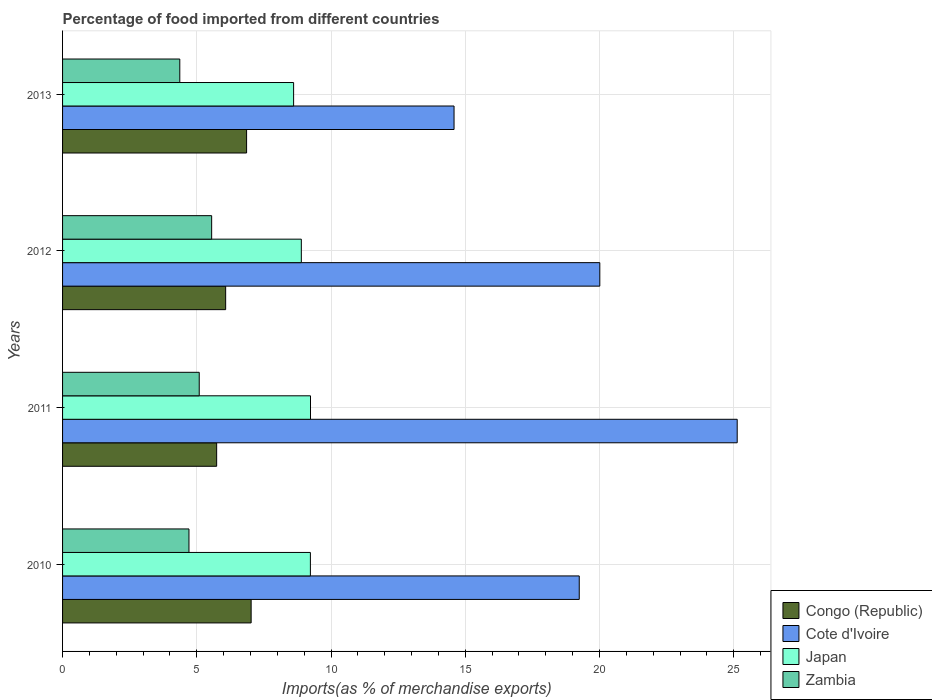Are the number of bars per tick equal to the number of legend labels?
Make the answer very short. Yes. Are the number of bars on each tick of the Y-axis equal?
Your answer should be compact. Yes. How many bars are there on the 2nd tick from the bottom?
Your answer should be compact. 4. What is the percentage of imports to different countries in Zambia in 2013?
Provide a short and direct response. 4.37. Across all years, what is the maximum percentage of imports to different countries in Cote d'Ivoire?
Ensure brevity in your answer.  25.13. Across all years, what is the minimum percentage of imports to different countries in Zambia?
Your answer should be compact. 4.37. In which year was the percentage of imports to different countries in Congo (Republic) maximum?
Keep it short and to the point. 2010. What is the total percentage of imports to different countries in Cote d'Ivoire in the graph?
Keep it short and to the point. 78.96. What is the difference between the percentage of imports to different countries in Zambia in 2011 and that in 2013?
Provide a succinct answer. 0.72. What is the difference between the percentage of imports to different countries in Cote d'Ivoire in 2010 and the percentage of imports to different countries in Zambia in 2011?
Keep it short and to the point. 14.15. What is the average percentage of imports to different countries in Cote d'Ivoire per year?
Provide a succinct answer. 19.74. In the year 2010, what is the difference between the percentage of imports to different countries in Zambia and percentage of imports to different countries in Congo (Republic)?
Provide a succinct answer. -2.32. What is the ratio of the percentage of imports to different countries in Cote d'Ivoire in 2010 to that in 2012?
Give a very brief answer. 0.96. Is the percentage of imports to different countries in Japan in 2012 less than that in 2013?
Give a very brief answer. No. Is the difference between the percentage of imports to different countries in Zambia in 2012 and 2013 greater than the difference between the percentage of imports to different countries in Congo (Republic) in 2012 and 2013?
Provide a short and direct response. Yes. What is the difference between the highest and the second highest percentage of imports to different countries in Cote d'Ivoire?
Keep it short and to the point. 5.12. What is the difference between the highest and the lowest percentage of imports to different countries in Cote d'Ivoire?
Your response must be concise. 10.55. Is the sum of the percentage of imports to different countries in Cote d'Ivoire in 2011 and 2013 greater than the maximum percentage of imports to different countries in Congo (Republic) across all years?
Keep it short and to the point. Yes. Is it the case that in every year, the sum of the percentage of imports to different countries in Zambia and percentage of imports to different countries in Congo (Republic) is greater than the sum of percentage of imports to different countries in Japan and percentage of imports to different countries in Cote d'Ivoire?
Your response must be concise. No. What does the 1st bar from the top in 2013 represents?
Keep it short and to the point. Zambia. What does the 2nd bar from the bottom in 2013 represents?
Make the answer very short. Cote d'Ivoire. Is it the case that in every year, the sum of the percentage of imports to different countries in Congo (Republic) and percentage of imports to different countries in Cote d'Ivoire is greater than the percentage of imports to different countries in Zambia?
Your answer should be compact. Yes. Are all the bars in the graph horizontal?
Keep it short and to the point. Yes. What is the difference between two consecutive major ticks on the X-axis?
Offer a terse response. 5. Are the values on the major ticks of X-axis written in scientific E-notation?
Offer a very short reply. No. Where does the legend appear in the graph?
Offer a very short reply. Bottom right. How are the legend labels stacked?
Your answer should be very brief. Vertical. What is the title of the graph?
Ensure brevity in your answer.  Percentage of food imported from different countries. Does "Ireland" appear as one of the legend labels in the graph?
Provide a succinct answer. No. What is the label or title of the X-axis?
Make the answer very short. Imports(as % of merchandise exports). What is the label or title of the Y-axis?
Your answer should be compact. Years. What is the Imports(as % of merchandise exports) in Congo (Republic) in 2010?
Offer a very short reply. 7.02. What is the Imports(as % of merchandise exports) in Cote d'Ivoire in 2010?
Provide a succinct answer. 19.24. What is the Imports(as % of merchandise exports) in Japan in 2010?
Keep it short and to the point. 9.23. What is the Imports(as % of merchandise exports) in Zambia in 2010?
Your response must be concise. 4.71. What is the Imports(as % of merchandise exports) of Congo (Republic) in 2011?
Offer a very short reply. 5.74. What is the Imports(as % of merchandise exports) of Cote d'Ivoire in 2011?
Make the answer very short. 25.13. What is the Imports(as % of merchandise exports) of Japan in 2011?
Ensure brevity in your answer.  9.23. What is the Imports(as % of merchandise exports) of Zambia in 2011?
Provide a succinct answer. 5.09. What is the Imports(as % of merchandise exports) of Congo (Republic) in 2012?
Provide a succinct answer. 6.07. What is the Imports(as % of merchandise exports) in Cote d'Ivoire in 2012?
Your answer should be compact. 20.01. What is the Imports(as % of merchandise exports) in Japan in 2012?
Make the answer very short. 8.89. What is the Imports(as % of merchandise exports) of Zambia in 2012?
Ensure brevity in your answer.  5.55. What is the Imports(as % of merchandise exports) of Congo (Republic) in 2013?
Provide a succinct answer. 6.85. What is the Imports(as % of merchandise exports) in Cote d'Ivoire in 2013?
Ensure brevity in your answer.  14.58. What is the Imports(as % of merchandise exports) in Japan in 2013?
Provide a short and direct response. 8.61. What is the Imports(as % of merchandise exports) of Zambia in 2013?
Your answer should be compact. 4.37. Across all years, what is the maximum Imports(as % of merchandise exports) in Congo (Republic)?
Give a very brief answer. 7.02. Across all years, what is the maximum Imports(as % of merchandise exports) of Cote d'Ivoire?
Provide a succinct answer. 25.13. Across all years, what is the maximum Imports(as % of merchandise exports) in Japan?
Your response must be concise. 9.23. Across all years, what is the maximum Imports(as % of merchandise exports) of Zambia?
Ensure brevity in your answer.  5.55. Across all years, what is the minimum Imports(as % of merchandise exports) in Congo (Republic)?
Offer a terse response. 5.74. Across all years, what is the minimum Imports(as % of merchandise exports) in Cote d'Ivoire?
Provide a succinct answer. 14.58. Across all years, what is the minimum Imports(as % of merchandise exports) in Japan?
Your answer should be compact. 8.61. Across all years, what is the minimum Imports(as % of merchandise exports) in Zambia?
Your response must be concise. 4.37. What is the total Imports(as % of merchandise exports) of Congo (Republic) in the graph?
Your answer should be compact. 25.69. What is the total Imports(as % of merchandise exports) in Cote d'Ivoire in the graph?
Keep it short and to the point. 78.96. What is the total Imports(as % of merchandise exports) in Japan in the graph?
Make the answer very short. 35.96. What is the total Imports(as % of merchandise exports) in Zambia in the graph?
Your response must be concise. 19.72. What is the difference between the Imports(as % of merchandise exports) of Congo (Republic) in 2010 and that in 2011?
Ensure brevity in your answer.  1.28. What is the difference between the Imports(as % of merchandise exports) of Cote d'Ivoire in 2010 and that in 2011?
Offer a terse response. -5.88. What is the difference between the Imports(as % of merchandise exports) of Japan in 2010 and that in 2011?
Keep it short and to the point. -0. What is the difference between the Imports(as % of merchandise exports) in Zambia in 2010 and that in 2011?
Provide a succinct answer. -0.38. What is the difference between the Imports(as % of merchandise exports) of Congo (Republic) in 2010 and that in 2012?
Offer a very short reply. 0.95. What is the difference between the Imports(as % of merchandise exports) in Cote d'Ivoire in 2010 and that in 2012?
Offer a terse response. -0.77. What is the difference between the Imports(as % of merchandise exports) in Japan in 2010 and that in 2012?
Give a very brief answer. 0.34. What is the difference between the Imports(as % of merchandise exports) in Zambia in 2010 and that in 2012?
Your response must be concise. -0.84. What is the difference between the Imports(as % of merchandise exports) in Congo (Republic) in 2010 and that in 2013?
Keep it short and to the point. 0.17. What is the difference between the Imports(as % of merchandise exports) in Cote d'Ivoire in 2010 and that in 2013?
Your response must be concise. 4.66. What is the difference between the Imports(as % of merchandise exports) in Japan in 2010 and that in 2013?
Your answer should be very brief. 0.63. What is the difference between the Imports(as % of merchandise exports) of Zambia in 2010 and that in 2013?
Offer a very short reply. 0.34. What is the difference between the Imports(as % of merchandise exports) in Congo (Republic) in 2011 and that in 2012?
Ensure brevity in your answer.  -0.34. What is the difference between the Imports(as % of merchandise exports) of Cote d'Ivoire in 2011 and that in 2012?
Offer a very short reply. 5.12. What is the difference between the Imports(as % of merchandise exports) in Japan in 2011 and that in 2012?
Provide a succinct answer. 0.34. What is the difference between the Imports(as % of merchandise exports) in Zambia in 2011 and that in 2012?
Give a very brief answer. -0.46. What is the difference between the Imports(as % of merchandise exports) in Congo (Republic) in 2011 and that in 2013?
Provide a succinct answer. -1.11. What is the difference between the Imports(as % of merchandise exports) of Cote d'Ivoire in 2011 and that in 2013?
Ensure brevity in your answer.  10.55. What is the difference between the Imports(as % of merchandise exports) in Japan in 2011 and that in 2013?
Offer a terse response. 0.63. What is the difference between the Imports(as % of merchandise exports) of Zambia in 2011 and that in 2013?
Ensure brevity in your answer.  0.72. What is the difference between the Imports(as % of merchandise exports) of Congo (Republic) in 2012 and that in 2013?
Make the answer very short. -0.78. What is the difference between the Imports(as % of merchandise exports) of Cote d'Ivoire in 2012 and that in 2013?
Keep it short and to the point. 5.43. What is the difference between the Imports(as % of merchandise exports) in Japan in 2012 and that in 2013?
Make the answer very short. 0.29. What is the difference between the Imports(as % of merchandise exports) of Zambia in 2012 and that in 2013?
Provide a succinct answer. 1.19. What is the difference between the Imports(as % of merchandise exports) of Congo (Republic) in 2010 and the Imports(as % of merchandise exports) of Cote d'Ivoire in 2011?
Provide a succinct answer. -18.1. What is the difference between the Imports(as % of merchandise exports) of Congo (Republic) in 2010 and the Imports(as % of merchandise exports) of Japan in 2011?
Your response must be concise. -2.21. What is the difference between the Imports(as % of merchandise exports) of Congo (Republic) in 2010 and the Imports(as % of merchandise exports) of Zambia in 2011?
Offer a very short reply. 1.93. What is the difference between the Imports(as % of merchandise exports) of Cote d'Ivoire in 2010 and the Imports(as % of merchandise exports) of Japan in 2011?
Your answer should be very brief. 10.01. What is the difference between the Imports(as % of merchandise exports) in Cote d'Ivoire in 2010 and the Imports(as % of merchandise exports) in Zambia in 2011?
Keep it short and to the point. 14.15. What is the difference between the Imports(as % of merchandise exports) in Japan in 2010 and the Imports(as % of merchandise exports) in Zambia in 2011?
Your answer should be very brief. 4.14. What is the difference between the Imports(as % of merchandise exports) in Congo (Republic) in 2010 and the Imports(as % of merchandise exports) in Cote d'Ivoire in 2012?
Your answer should be compact. -12.99. What is the difference between the Imports(as % of merchandise exports) in Congo (Republic) in 2010 and the Imports(as % of merchandise exports) in Japan in 2012?
Give a very brief answer. -1.87. What is the difference between the Imports(as % of merchandise exports) in Congo (Republic) in 2010 and the Imports(as % of merchandise exports) in Zambia in 2012?
Make the answer very short. 1.47. What is the difference between the Imports(as % of merchandise exports) of Cote d'Ivoire in 2010 and the Imports(as % of merchandise exports) of Japan in 2012?
Your answer should be compact. 10.35. What is the difference between the Imports(as % of merchandise exports) in Cote d'Ivoire in 2010 and the Imports(as % of merchandise exports) in Zambia in 2012?
Offer a very short reply. 13.69. What is the difference between the Imports(as % of merchandise exports) of Japan in 2010 and the Imports(as % of merchandise exports) of Zambia in 2012?
Ensure brevity in your answer.  3.68. What is the difference between the Imports(as % of merchandise exports) in Congo (Republic) in 2010 and the Imports(as % of merchandise exports) in Cote d'Ivoire in 2013?
Give a very brief answer. -7.56. What is the difference between the Imports(as % of merchandise exports) of Congo (Republic) in 2010 and the Imports(as % of merchandise exports) of Japan in 2013?
Your response must be concise. -1.58. What is the difference between the Imports(as % of merchandise exports) in Congo (Republic) in 2010 and the Imports(as % of merchandise exports) in Zambia in 2013?
Make the answer very short. 2.66. What is the difference between the Imports(as % of merchandise exports) of Cote d'Ivoire in 2010 and the Imports(as % of merchandise exports) of Japan in 2013?
Keep it short and to the point. 10.64. What is the difference between the Imports(as % of merchandise exports) of Cote d'Ivoire in 2010 and the Imports(as % of merchandise exports) of Zambia in 2013?
Offer a terse response. 14.88. What is the difference between the Imports(as % of merchandise exports) in Japan in 2010 and the Imports(as % of merchandise exports) in Zambia in 2013?
Keep it short and to the point. 4.86. What is the difference between the Imports(as % of merchandise exports) of Congo (Republic) in 2011 and the Imports(as % of merchandise exports) of Cote d'Ivoire in 2012?
Your answer should be compact. -14.27. What is the difference between the Imports(as % of merchandise exports) in Congo (Republic) in 2011 and the Imports(as % of merchandise exports) in Japan in 2012?
Keep it short and to the point. -3.15. What is the difference between the Imports(as % of merchandise exports) of Congo (Republic) in 2011 and the Imports(as % of merchandise exports) of Zambia in 2012?
Provide a short and direct response. 0.19. What is the difference between the Imports(as % of merchandise exports) in Cote d'Ivoire in 2011 and the Imports(as % of merchandise exports) in Japan in 2012?
Make the answer very short. 16.23. What is the difference between the Imports(as % of merchandise exports) in Cote d'Ivoire in 2011 and the Imports(as % of merchandise exports) in Zambia in 2012?
Provide a short and direct response. 19.57. What is the difference between the Imports(as % of merchandise exports) in Japan in 2011 and the Imports(as % of merchandise exports) in Zambia in 2012?
Your response must be concise. 3.68. What is the difference between the Imports(as % of merchandise exports) in Congo (Republic) in 2011 and the Imports(as % of merchandise exports) in Cote d'Ivoire in 2013?
Offer a terse response. -8.84. What is the difference between the Imports(as % of merchandise exports) in Congo (Republic) in 2011 and the Imports(as % of merchandise exports) in Japan in 2013?
Give a very brief answer. -2.87. What is the difference between the Imports(as % of merchandise exports) of Congo (Republic) in 2011 and the Imports(as % of merchandise exports) of Zambia in 2013?
Ensure brevity in your answer.  1.37. What is the difference between the Imports(as % of merchandise exports) of Cote d'Ivoire in 2011 and the Imports(as % of merchandise exports) of Japan in 2013?
Offer a very short reply. 16.52. What is the difference between the Imports(as % of merchandise exports) in Cote d'Ivoire in 2011 and the Imports(as % of merchandise exports) in Zambia in 2013?
Your answer should be compact. 20.76. What is the difference between the Imports(as % of merchandise exports) in Japan in 2011 and the Imports(as % of merchandise exports) in Zambia in 2013?
Offer a terse response. 4.87. What is the difference between the Imports(as % of merchandise exports) of Congo (Republic) in 2012 and the Imports(as % of merchandise exports) of Cote d'Ivoire in 2013?
Ensure brevity in your answer.  -8.51. What is the difference between the Imports(as % of merchandise exports) of Congo (Republic) in 2012 and the Imports(as % of merchandise exports) of Japan in 2013?
Make the answer very short. -2.53. What is the difference between the Imports(as % of merchandise exports) of Congo (Republic) in 2012 and the Imports(as % of merchandise exports) of Zambia in 2013?
Your answer should be compact. 1.71. What is the difference between the Imports(as % of merchandise exports) in Cote d'Ivoire in 2012 and the Imports(as % of merchandise exports) in Japan in 2013?
Ensure brevity in your answer.  11.41. What is the difference between the Imports(as % of merchandise exports) in Cote d'Ivoire in 2012 and the Imports(as % of merchandise exports) in Zambia in 2013?
Offer a very short reply. 15.64. What is the difference between the Imports(as % of merchandise exports) in Japan in 2012 and the Imports(as % of merchandise exports) in Zambia in 2013?
Your response must be concise. 4.53. What is the average Imports(as % of merchandise exports) in Congo (Republic) per year?
Offer a terse response. 6.42. What is the average Imports(as % of merchandise exports) of Cote d'Ivoire per year?
Ensure brevity in your answer.  19.74. What is the average Imports(as % of merchandise exports) in Japan per year?
Provide a short and direct response. 8.99. What is the average Imports(as % of merchandise exports) in Zambia per year?
Offer a very short reply. 4.93. In the year 2010, what is the difference between the Imports(as % of merchandise exports) of Congo (Republic) and Imports(as % of merchandise exports) of Cote d'Ivoire?
Your response must be concise. -12.22. In the year 2010, what is the difference between the Imports(as % of merchandise exports) in Congo (Republic) and Imports(as % of merchandise exports) in Japan?
Provide a succinct answer. -2.21. In the year 2010, what is the difference between the Imports(as % of merchandise exports) of Congo (Republic) and Imports(as % of merchandise exports) of Zambia?
Provide a short and direct response. 2.32. In the year 2010, what is the difference between the Imports(as % of merchandise exports) in Cote d'Ivoire and Imports(as % of merchandise exports) in Japan?
Your response must be concise. 10.01. In the year 2010, what is the difference between the Imports(as % of merchandise exports) of Cote d'Ivoire and Imports(as % of merchandise exports) of Zambia?
Your answer should be compact. 14.54. In the year 2010, what is the difference between the Imports(as % of merchandise exports) of Japan and Imports(as % of merchandise exports) of Zambia?
Your answer should be compact. 4.52. In the year 2011, what is the difference between the Imports(as % of merchandise exports) in Congo (Republic) and Imports(as % of merchandise exports) in Cote d'Ivoire?
Offer a very short reply. -19.39. In the year 2011, what is the difference between the Imports(as % of merchandise exports) in Congo (Republic) and Imports(as % of merchandise exports) in Japan?
Keep it short and to the point. -3.5. In the year 2011, what is the difference between the Imports(as % of merchandise exports) of Congo (Republic) and Imports(as % of merchandise exports) of Zambia?
Your answer should be compact. 0.65. In the year 2011, what is the difference between the Imports(as % of merchandise exports) in Cote d'Ivoire and Imports(as % of merchandise exports) in Japan?
Your answer should be compact. 15.89. In the year 2011, what is the difference between the Imports(as % of merchandise exports) in Cote d'Ivoire and Imports(as % of merchandise exports) in Zambia?
Offer a very short reply. 20.04. In the year 2011, what is the difference between the Imports(as % of merchandise exports) of Japan and Imports(as % of merchandise exports) of Zambia?
Provide a succinct answer. 4.14. In the year 2012, what is the difference between the Imports(as % of merchandise exports) in Congo (Republic) and Imports(as % of merchandise exports) in Cote d'Ivoire?
Your response must be concise. -13.94. In the year 2012, what is the difference between the Imports(as % of merchandise exports) of Congo (Republic) and Imports(as % of merchandise exports) of Japan?
Offer a very short reply. -2.82. In the year 2012, what is the difference between the Imports(as % of merchandise exports) of Congo (Republic) and Imports(as % of merchandise exports) of Zambia?
Keep it short and to the point. 0.52. In the year 2012, what is the difference between the Imports(as % of merchandise exports) of Cote d'Ivoire and Imports(as % of merchandise exports) of Japan?
Make the answer very short. 11.12. In the year 2012, what is the difference between the Imports(as % of merchandise exports) in Cote d'Ivoire and Imports(as % of merchandise exports) in Zambia?
Provide a succinct answer. 14.46. In the year 2012, what is the difference between the Imports(as % of merchandise exports) in Japan and Imports(as % of merchandise exports) in Zambia?
Your answer should be very brief. 3.34. In the year 2013, what is the difference between the Imports(as % of merchandise exports) of Congo (Republic) and Imports(as % of merchandise exports) of Cote d'Ivoire?
Give a very brief answer. -7.73. In the year 2013, what is the difference between the Imports(as % of merchandise exports) of Congo (Republic) and Imports(as % of merchandise exports) of Japan?
Ensure brevity in your answer.  -1.75. In the year 2013, what is the difference between the Imports(as % of merchandise exports) in Congo (Republic) and Imports(as % of merchandise exports) in Zambia?
Give a very brief answer. 2.49. In the year 2013, what is the difference between the Imports(as % of merchandise exports) of Cote d'Ivoire and Imports(as % of merchandise exports) of Japan?
Your answer should be very brief. 5.98. In the year 2013, what is the difference between the Imports(as % of merchandise exports) in Cote d'Ivoire and Imports(as % of merchandise exports) in Zambia?
Provide a succinct answer. 10.21. In the year 2013, what is the difference between the Imports(as % of merchandise exports) of Japan and Imports(as % of merchandise exports) of Zambia?
Your answer should be very brief. 4.24. What is the ratio of the Imports(as % of merchandise exports) of Congo (Republic) in 2010 to that in 2011?
Your answer should be very brief. 1.22. What is the ratio of the Imports(as % of merchandise exports) in Cote d'Ivoire in 2010 to that in 2011?
Ensure brevity in your answer.  0.77. What is the ratio of the Imports(as % of merchandise exports) in Japan in 2010 to that in 2011?
Your answer should be compact. 1. What is the ratio of the Imports(as % of merchandise exports) in Zambia in 2010 to that in 2011?
Make the answer very short. 0.92. What is the ratio of the Imports(as % of merchandise exports) in Congo (Republic) in 2010 to that in 2012?
Your answer should be compact. 1.16. What is the ratio of the Imports(as % of merchandise exports) in Cote d'Ivoire in 2010 to that in 2012?
Offer a very short reply. 0.96. What is the ratio of the Imports(as % of merchandise exports) of Japan in 2010 to that in 2012?
Provide a succinct answer. 1.04. What is the ratio of the Imports(as % of merchandise exports) of Zambia in 2010 to that in 2012?
Your answer should be very brief. 0.85. What is the ratio of the Imports(as % of merchandise exports) in Congo (Republic) in 2010 to that in 2013?
Your answer should be very brief. 1.02. What is the ratio of the Imports(as % of merchandise exports) of Cote d'Ivoire in 2010 to that in 2013?
Your answer should be very brief. 1.32. What is the ratio of the Imports(as % of merchandise exports) in Japan in 2010 to that in 2013?
Your response must be concise. 1.07. What is the ratio of the Imports(as % of merchandise exports) in Zambia in 2010 to that in 2013?
Your answer should be compact. 1.08. What is the ratio of the Imports(as % of merchandise exports) in Congo (Republic) in 2011 to that in 2012?
Offer a terse response. 0.94. What is the ratio of the Imports(as % of merchandise exports) of Cote d'Ivoire in 2011 to that in 2012?
Your answer should be very brief. 1.26. What is the ratio of the Imports(as % of merchandise exports) in Zambia in 2011 to that in 2012?
Make the answer very short. 0.92. What is the ratio of the Imports(as % of merchandise exports) in Congo (Republic) in 2011 to that in 2013?
Keep it short and to the point. 0.84. What is the ratio of the Imports(as % of merchandise exports) in Cote d'Ivoire in 2011 to that in 2013?
Make the answer very short. 1.72. What is the ratio of the Imports(as % of merchandise exports) in Japan in 2011 to that in 2013?
Give a very brief answer. 1.07. What is the ratio of the Imports(as % of merchandise exports) of Zambia in 2011 to that in 2013?
Offer a very short reply. 1.17. What is the ratio of the Imports(as % of merchandise exports) in Congo (Republic) in 2012 to that in 2013?
Ensure brevity in your answer.  0.89. What is the ratio of the Imports(as % of merchandise exports) of Cote d'Ivoire in 2012 to that in 2013?
Offer a very short reply. 1.37. What is the ratio of the Imports(as % of merchandise exports) of Japan in 2012 to that in 2013?
Ensure brevity in your answer.  1.03. What is the ratio of the Imports(as % of merchandise exports) of Zambia in 2012 to that in 2013?
Make the answer very short. 1.27. What is the difference between the highest and the second highest Imports(as % of merchandise exports) of Congo (Republic)?
Your answer should be very brief. 0.17. What is the difference between the highest and the second highest Imports(as % of merchandise exports) in Cote d'Ivoire?
Your answer should be very brief. 5.12. What is the difference between the highest and the second highest Imports(as % of merchandise exports) of Japan?
Your answer should be compact. 0. What is the difference between the highest and the second highest Imports(as % of merchandise exports) of Zambia?
Offer a very short reply. 0.46. What is the difference between the highest and the lowest Imports(as % of merchandise exports) in Congo (Republic)?
Give a very brief answer. 1.28. What is the difference between the highest and the lowest Imports(as % of merchandise exports) of Cote d'Ivoire?
Ensure brevity in your answer.  10.55. What is the difference between the highest and the lowest Imports(as % of merchandise exports) in Japan?
Your answer should be very brief. 0.63. What is the difference between the highest and the lowest Imports(as % of merchandise exports) of Zambia?
Provide a short and direct response. 1.19. 